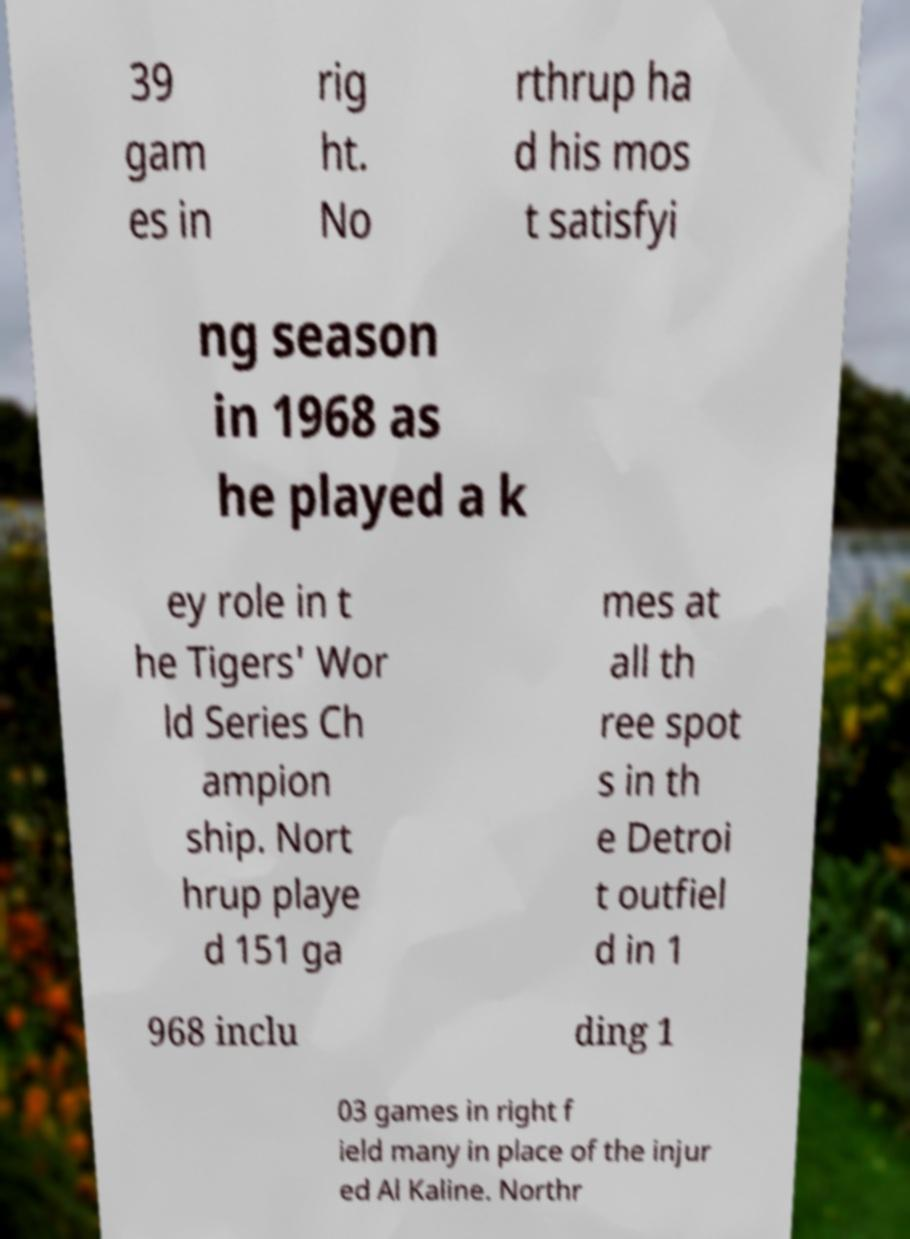Please read and relay the text visible in this image. What does it say? 39 gam es in rig ht. No rthrup ha d his mos t satisfyi ng season in 1968 as he played a k ey role in t he Tigers' Wor ld Series Ch ampion ship. Nort hrup playe d 151 ga mes at all th ree spot s in th e Detroi t outfiel d in 1 968 inclu ding 1 03 games in right f ield many in place of the injur ed Al Kaline. Northr 